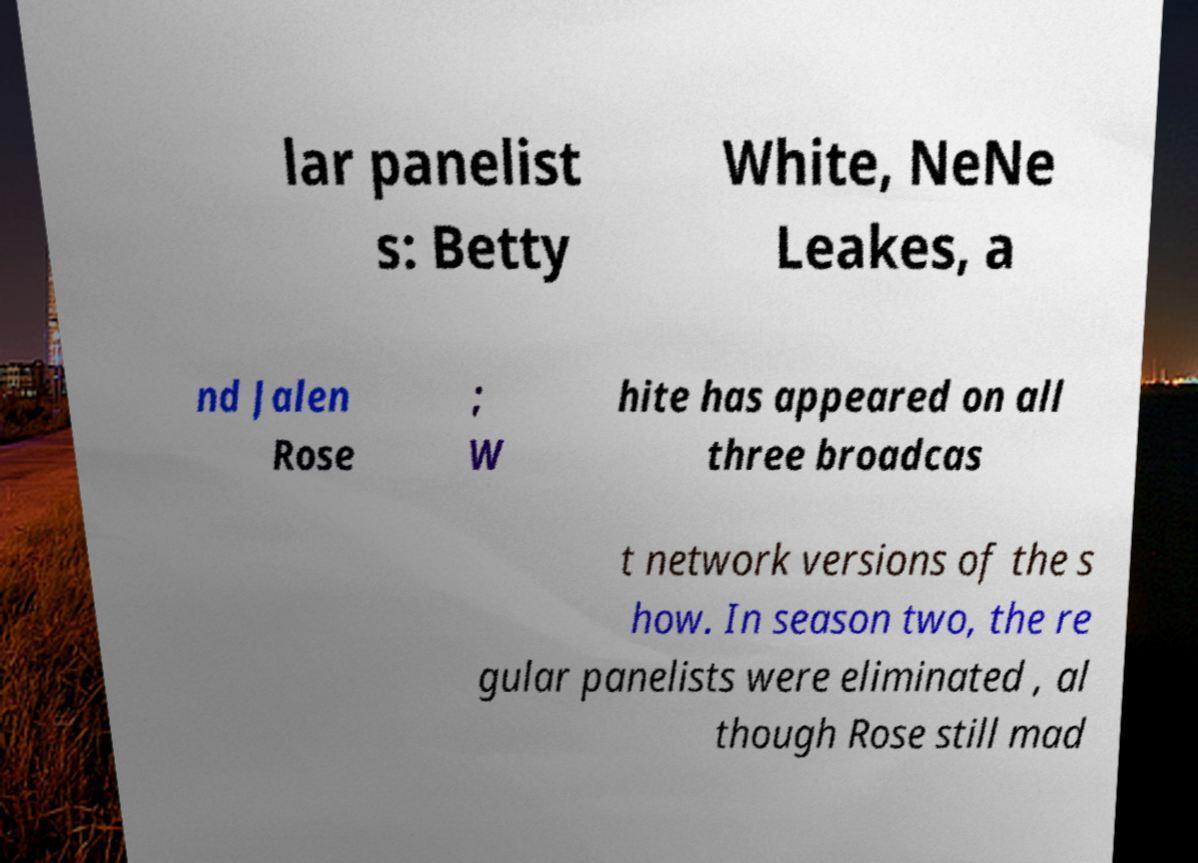Could you extract and type out the text from this image? lar panelist s: Betty White, NeNe Leakes, a nd Jalen Rose ; W hite has appeared on all three broadcas t network versions of the s how. In season two, the re gular panelists were eliminated , al though Rose still mad 